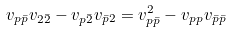<formula> <loc_0><loc_0><loc_500><loc_500>v _ { p \bar { p } } v _ { 2 \bar { 2 } } - v _ { p \bar { 2 } } v _ { \bar { p } 2 } = v _ { p \bar { p } } ^ { 2 } - v _ { p p } v _ { \bar { p } \bar { p } }</formula> 